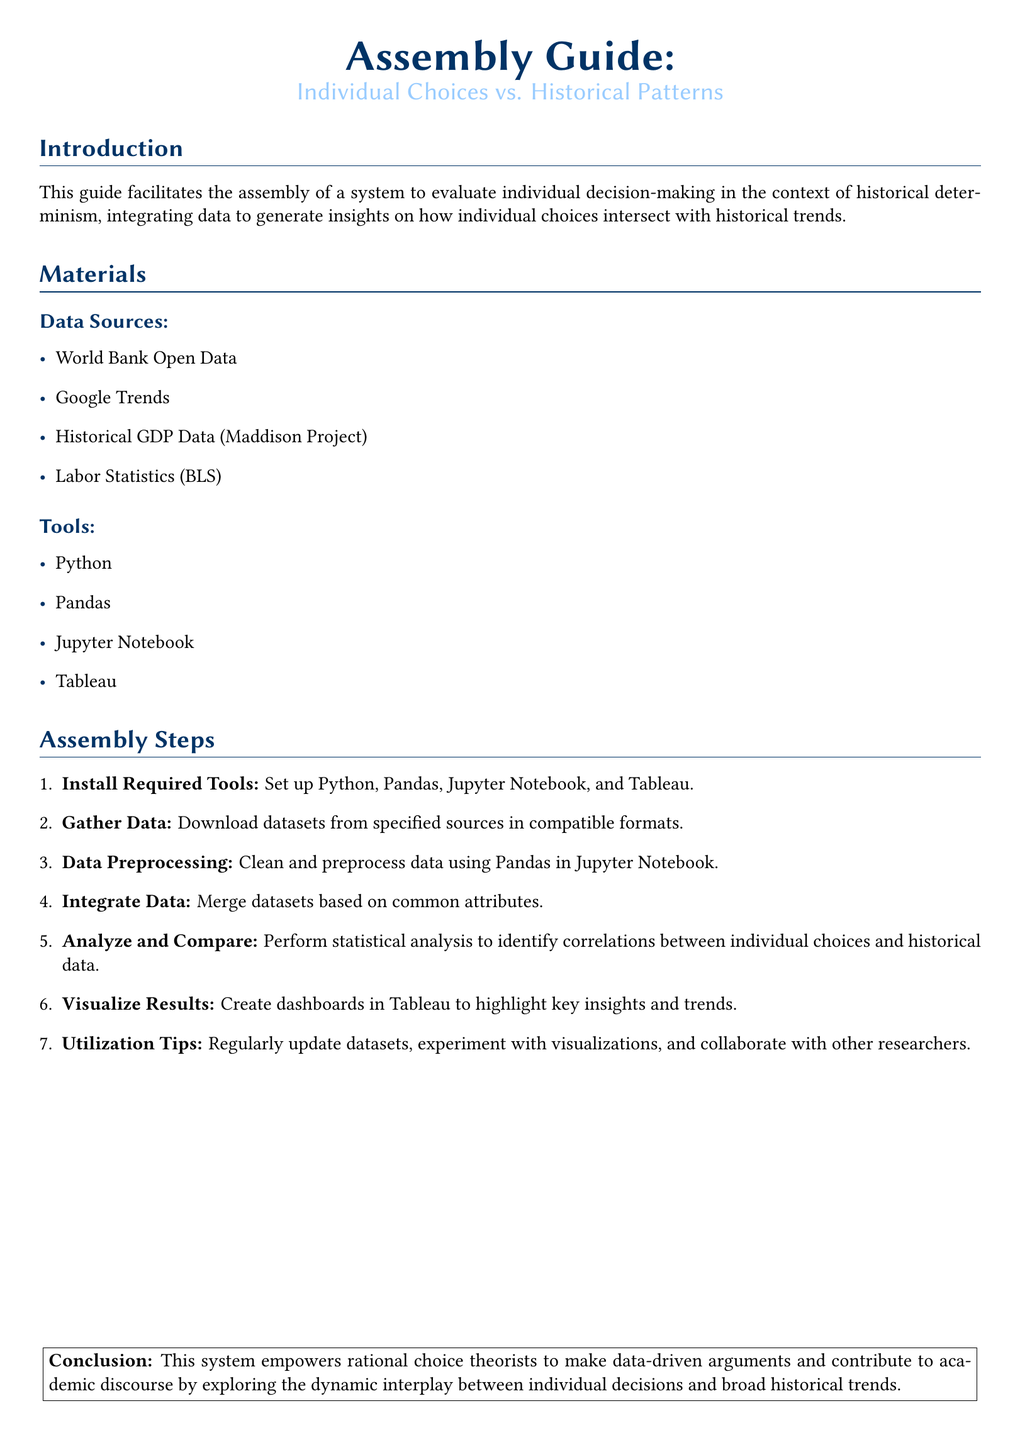What is the title of the document? The title of the document is highlighted at the beginning, outlining the purpose of the assembly guide.
Answer: Assembly Guide: Individual Choices vs. Historical Patterns What is the first step in the assembly instructions? The assembly instructions list steps in order, starting with the installation of necessary tools.
Answer: Install Required Tools Which data source is mentioned first? The data sources are listed in a specific order, with the first being World Bank Open Data.
Answer: World Bank Open Data What tool is used for data analysis? The document lists the tools required, with Pandas specifically mentioned for data analysis.
Answer: Pandas How many data sources are listed? The number of data sources is counted from the list provided in the materials section of the document.
Answer: Four What is the last step provided in the assembly instructions? The assembly instructions conclude with utilization tips, serving as the final step in the process.
Answer: Utilization Tips Which visualization tool is mentioned? The document specifies which tool is utilized to create visual dashboards for analysis.
Answer: Tableau What is the main purpose of this assembly guide? The document summarizes its aim to assist in evaluating the interplay between individual decision-making and historical patterns.
Answer: Evaluate individual decision-making What should users do regularly according to the utilization tips? The utilization tips suggest a specific action to maintain the relevance and integrity of the data used in the analysis.
Answer: Update datasets 